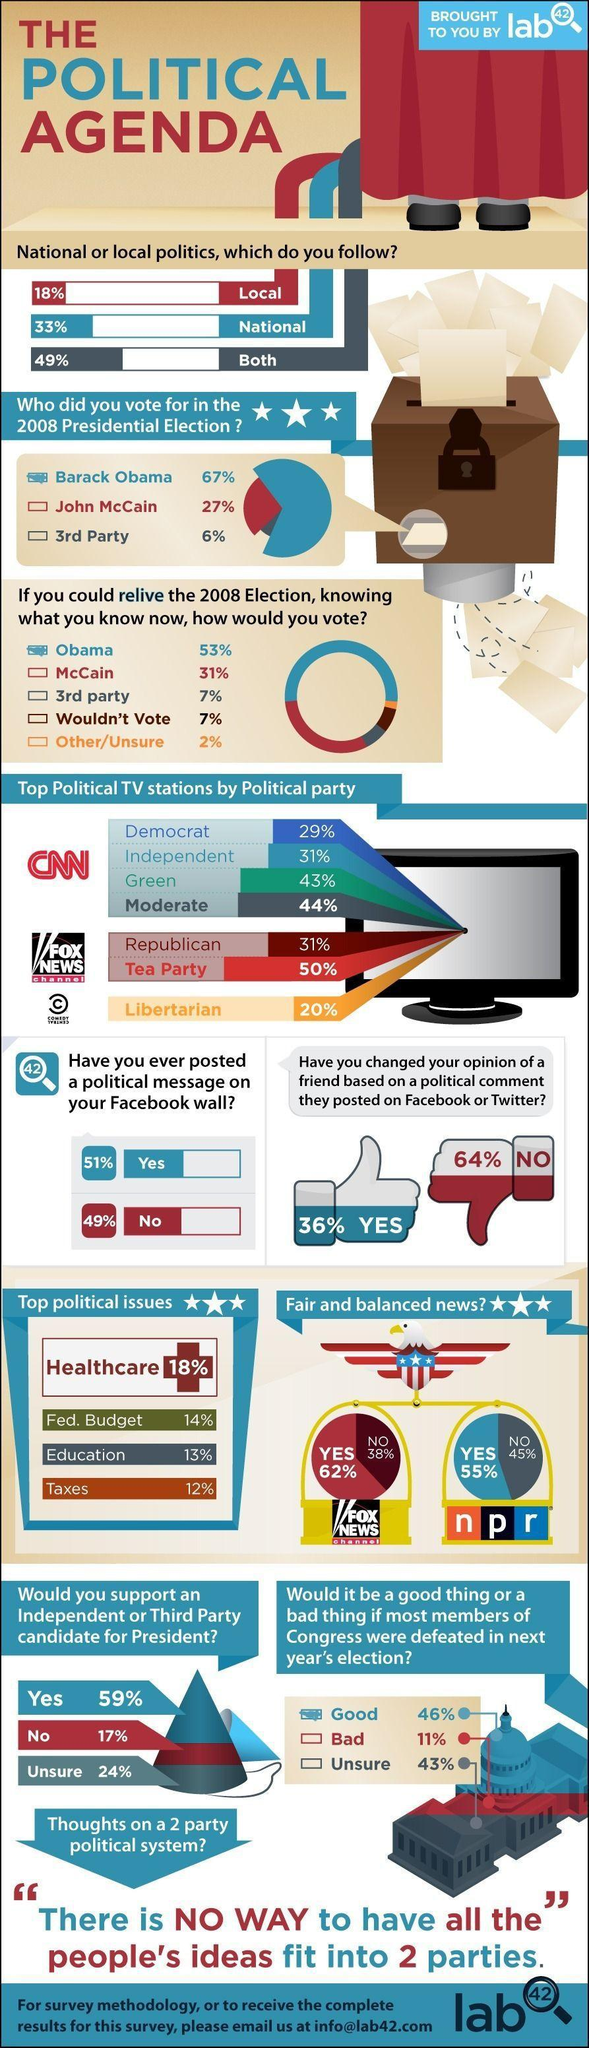Who does the majority of the Americans voted in the 2008 Presidential Election as per the survey?
Answer the question with a short phrase. Barack Obama What percent of Americans didn't ever posted a political message on their facebook wall according to the survey? 49% What percent of Americans follow only the national politics according to the survey? 33% Which are the top political parties for Fox New Channel Republican, Tea Party What percent of Americans voted for John McGain in the 2008 Presidential Election as per the survey? 27% Which is the top political issue after heath care Fed. Budget What percent of Americans follow both national & local politics according to the survey? 49% Which news channel is the majority of then people think provided fair and balanced news Fox News Channel What percent of Americans support an Independent or third party candidate for the President according to the survey? 59% 